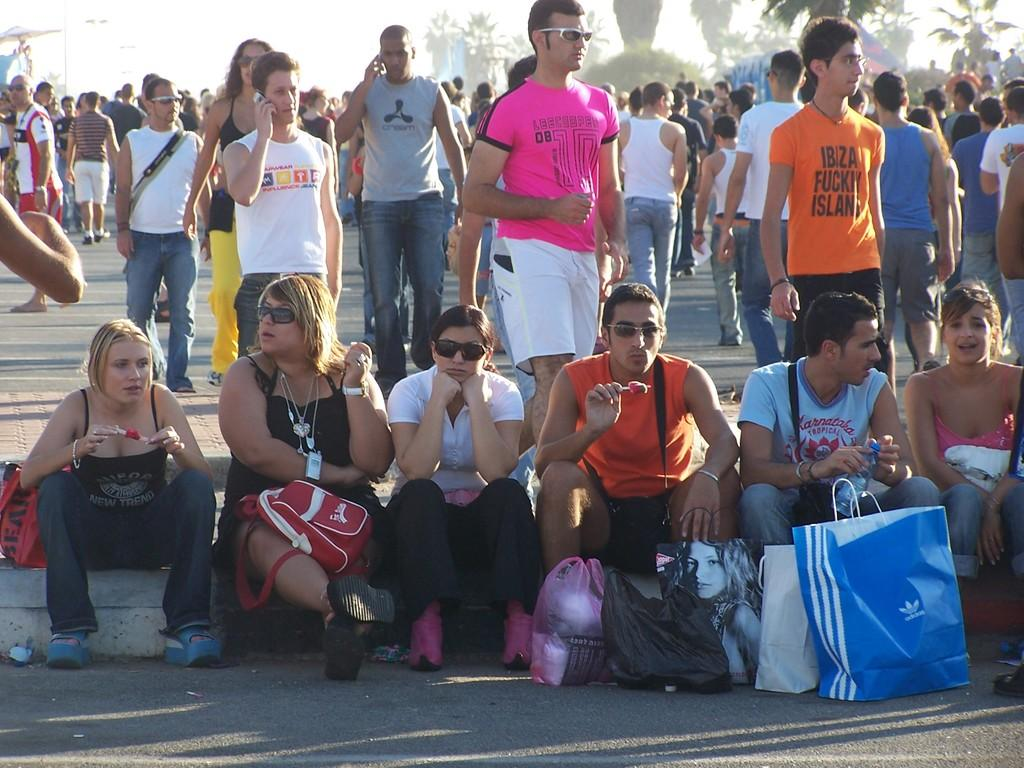<image>
Offer a succinct explanation of the picture presented. Six young people are sitting down on a curb and one of the young men is wearing a shirt with the brand Karnataka Tropical on it. 